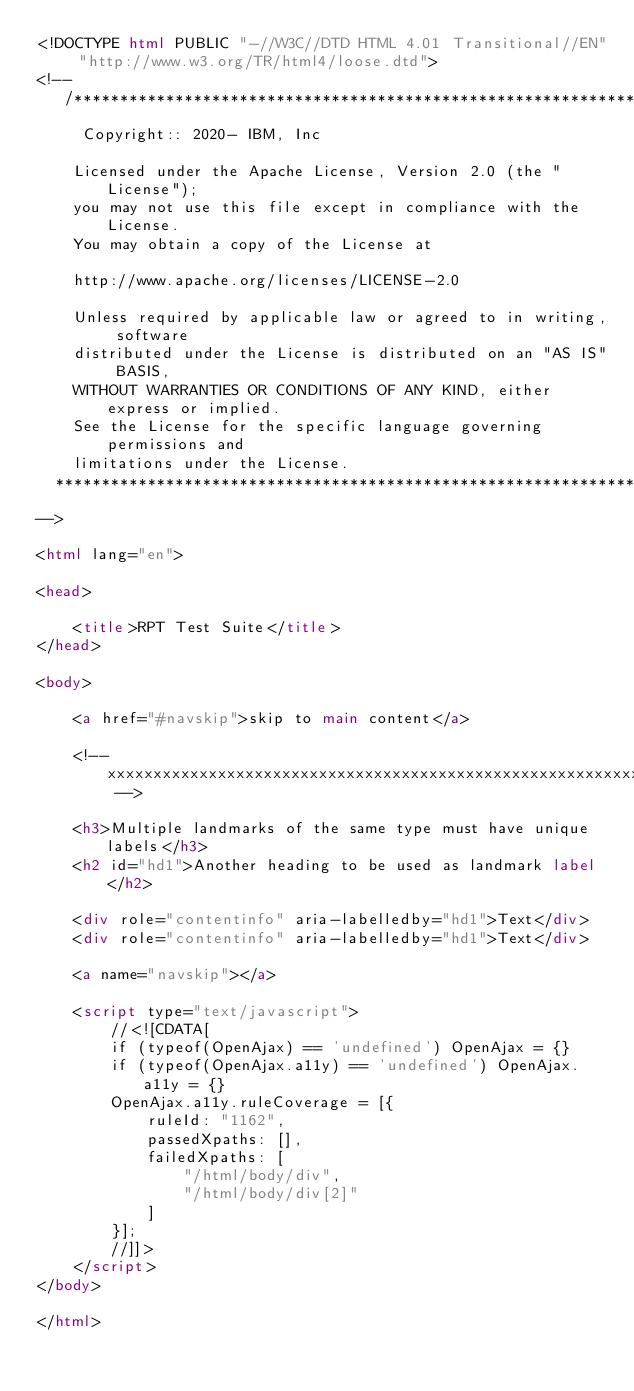<code> <loc_0><loc_0><loc_500><loc_500><_HTML_><!DOCTYPE html PUBLIC "-//W3C//DTD HTML 4.01 Transitional//EN" "http://www.w3.org/TR/html4/loose.dtd">
<!--
   /******************************************************************************
     Copyright:: 2020- IBM, Inc

    Licensed under the Apache License, Version 2.0 (the "License");
    you may not use this file except in compliance with the License.
    You may obtain a copy of the License at

    http://www.apache.org/licenses/LICENSE-2.0

    Unless required by applicable law or agreed to in writing, software
    distributed under the License is distributed on an "AS IS" BASIS,
    WITHOUT WARRANTIES OR CONDITIONS OF ANY KIND, either express or implied.
    See the License for the specific language governing permissions and
    limitations under the License.
  *****************************************************************************/
-->

<html lang="en">

<head>

    <title>RPT Test Suite</title>
</head>

<body>

    <a href="#navskip">skip to main content</a>

    <!-- xxxxxxxxxxxxxxxxxxxxxxxxxxxxxxxxxxxxxxxxxxxxxxxxxxxxxxxxxxxxxxxxxxx -->

    <h3>Multiple landmarks of the same type must have unique labels</h3>
    <h2 id="hd1">Another heading to be used as landmark label</h2>

    <div role="contentinfo" aria-labelledby="hd1">Text</div>
    <div role="contentinfo" aria-labelledby="hd1">Text</div>

    <a name="navskip"></a>

    <script type="text/javascript">
        //<![CDATA[
        if (typeof(OpenAjax) == 'undefined') OpenAjax = {}
        if (typeof(OpenAjax.a11y) == 'undefined') OpenAjax.a11y = {}
        OpenAjax.a11y.ruleCoverage = [{
            ruleId: "1162",
            passedXpaths: [],
            failedXpaths: [
                "/html/body/div",
                "/html/body/div[2]"
            ]
        }];
        //]]>
    </script>
</body>

</html></code> 